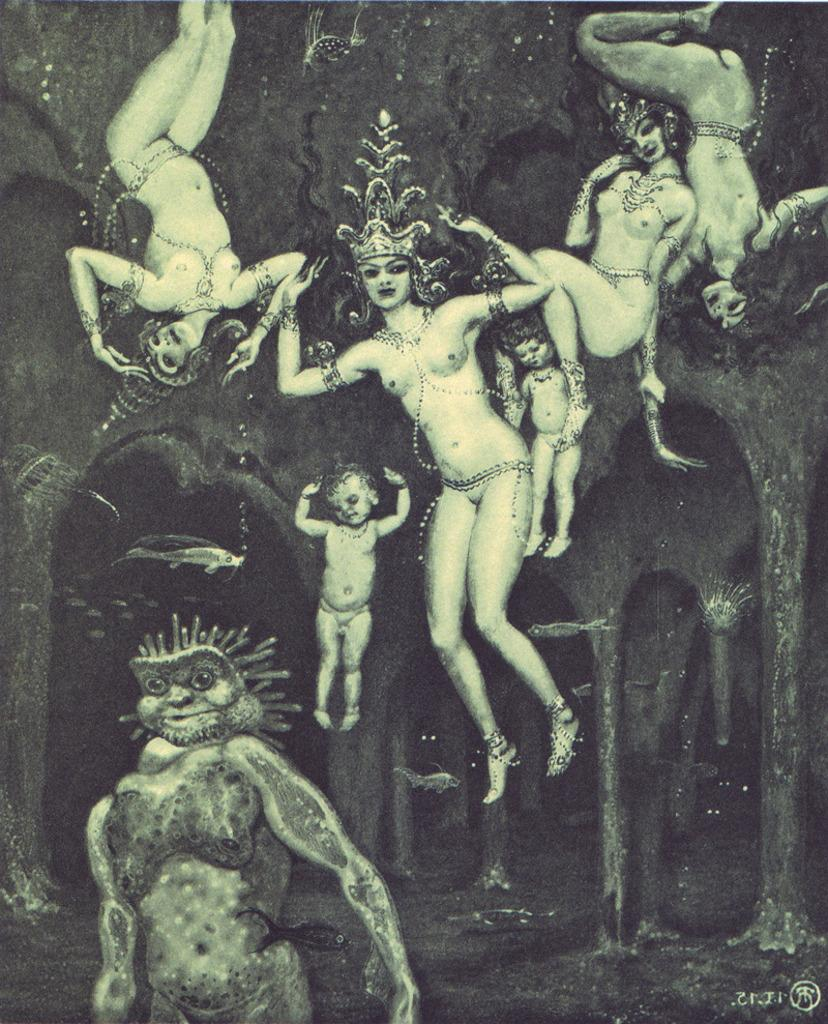What is the main subject of the image? There is a painting in the image. Who or what is depicted in the painting? The painting features women and kids. What architectural elements can be seen in the image? There are pillars in the image. How does the industry depicted in the painting contribute to the slip of the kids? There is no industry depicted in the painting, and the kids are not shown slipping. 